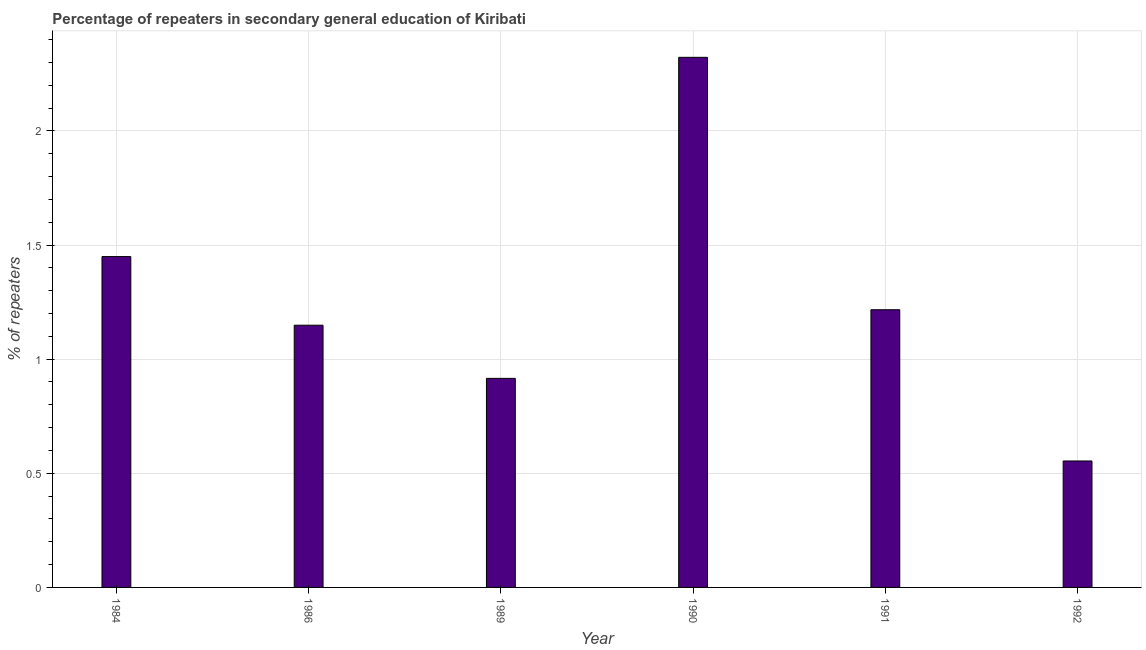What is the title of the graph?
Offer a terse response. Percentage of repeaters in secondary general education of Kiribati. What is the label or title of the Y-axis?
Your answer should be very brief. % of repeaters. What is the percentage of repeaters in 1986?
Provide a short and direct response. 1.15. Across all years, what is the maximum percentage of repeaters?
Make the answer very short. 2.32. Across all years, what is the minimum percentage of repeaters?
Keep it short and to the point. 0.55. What is the sum of the percentage of repeaters?
Give a very brief answer. 7.61. What is the difference between the percentage of repeaters in 1991 and 1992?
Offer a very short reply. 0.66. What is the average percentage of repeaters per year?
Your answer should be compact. 1.27. What is the median percentage of repeaters?
Provide a short and direct response. 1.18. In how many years, is the percentage of repeaters greater than 1.4 %?
Make the answer very short. 2. What is the ratio of the percentage of repeaters in 1986 to that in 1990?
Your response must be concise. 0.49. Is the difference between the percentage of repeaters in 1986 and 1992 greater than the difference between any two years?
Your answer should be very brief. No. What is the difference between the highest and the second highest percentage of repeaters?
Ensure brevity in your answer.  0.87. Is the sum of the percentage of repeaters in 1990 and 1992 greater than the maximum percentage of repeaters across all years?
Offer a terse response. Yes. What is the difference between the highest and the lowest percentage of repeaters?
Your answer should be compact. 1.77. In how many years, is the percentage of repeaters greater than the average percentage of repeaters taken over all years?
Your response must be concise. 2. How many bars are there?
Ensure brevity in your answer.  6. Are all the bars in the graph horizontal?
Keep it short and to the point. No. How many years are there in the graph?
Offer a terse response. 6. Are the values on the major ticks of Y-axis written in scientific E-notation?
Offer a very short reply. No. What is the % of repeaters in 1984?
Your answer should be very brief. 1.45. What is the % of repeaters of 1986?
Ensure brevity in your answer.  1.15. What is the % of repeaters of 1989?
Provide a short and direct response. 0.92. What is the % of repeaters in 1990?
Give a very brief answer. 2.32. What is the % of repeaters of 1991?
Keep it short and to the point. 1.22. What is the % of repeaters of 1992?
Provide a short and direct response. 0.55. What is the difference between the % of repeaters in 1984 and 1986?
Provide a short and direct response. 0.3. What is the difference between the % of repeaters in 1984 and 1989?
Offer a very short reply. 0.53. What is the difference between the % of repeaters in 1984 and 1990?
Keep it short and to the point. -0.87. What is the difference between the % of repeaters in 1984 and 1991?
Provide a succinct answer. 0.23. What is the difference between the % of repeaters in 1984 and 1992?
Your answer should be very brief. 0.9. What is the difference between the % of repeaters in 1986 and 1989?
Give a very brief answer. 0.23. What is the difference between the % of repeaters in 1986 and 1990?
Your answer should be very brief. -1.17. What is the difference between the % of repeaters in 1986 and 1991?
Your answer should be compact. -0.07. What is the difference between the % of repeaters in 1986 and 1992?
Your answer should be compact. 0.59. What is the difference between the % of repeaters in 1989 and 1990?
Your answer should be compact. -1.41. What is the difference between the % of repeaters in 1989 and 1991?
Provide a succinct answer. -0.3. What is the difference between the % of repeaters in 1989 and 1992?
Ensure brevity in your answer.  0.36. What is the difference between the % of repeaters in 1990 and 1991?
Offer a terse response. 1.11. What is the difference between the % of repeaters in 1990 and 1992?
Offer a terse response. 1.77. What is the difference between the % of repeaters in 1991 and 1992?
Keep it short and to the point. 0.66. What is the ratio of the % of repeaters in 1984 to that in 1986?
Your answer should be compact. 1.26. What is the ratio of the % of repeaters in 1984 to that in 1989?
Offer a very short reply. 1.58. What is the ratio of the % of repeaters in 1984 to that in 1990?
Make the answer very short. 0.62. What is the ratio of the % of repeaters in 1984 to that in 1991?
Your answer should be very brief. 1.19. What is the ratio of the % of repeaters in 1984 to that in 1992?
Your answer should be very brief. 2.62. What is the ratio of the % of repeaters in 1986 to that in 1989?
Provide a short and direct response. 1.25. What is the ratio of the % of repeaters in 1986 to that in 1990?
Your response must be concise. 0.49. What is the ratio of the % of repeaters in 1986 to that in 1991?
Your answer should be compact. 0.94. What is the ratio of the % of repeaters in 1986 to that in 1992?
Give a very brief answer. 2.07. What is the ratio of the % of repeaters in 1989 to that in 1990?
Keep it short and to the point. 0.39. What is the ratio of the % of repeaters in 1989 to that in 1991?
Provide a short and direct response. 0.75. What is the ratio of the % of repeaters in 1989 to that in 1992?
Provide a short and direct response. 1.65. What is the ratio of the % of repeaters in 1990 to that in 1991?
Provide a short and direct response. 1.91. What is the ratio of the % of repeaters in 1990 to that in 1992?
Offer a terse response. 4.19. What is the ratio of the % of repeaters in 1991 to that in 1992?
Ensure brevity in your answer.  2.2. 